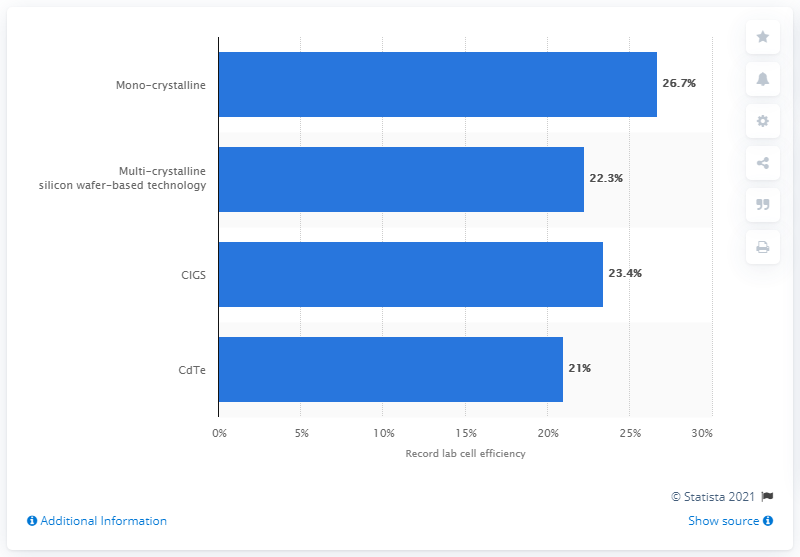List a handful of essential elements in this visual. In 2019, the efficiency of mono-crystalline solar cells was reported to be 26.7%. 